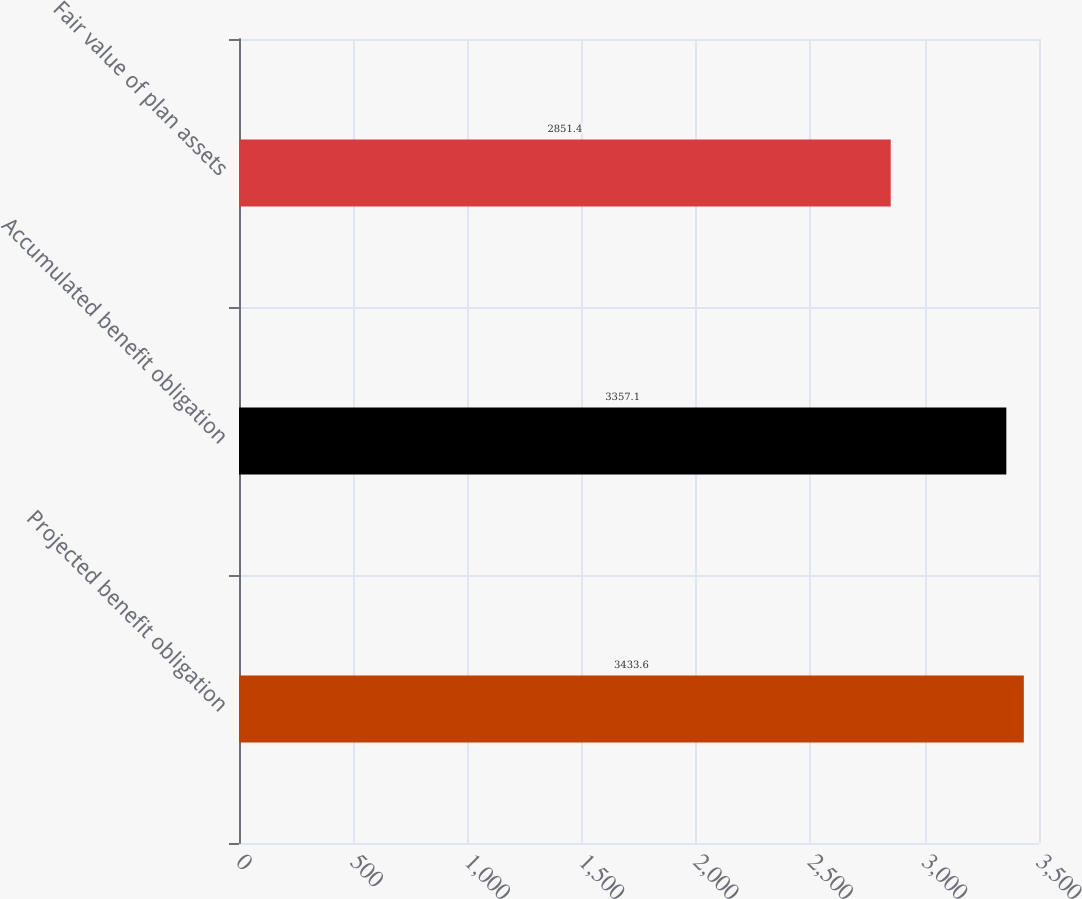<chart> <loc_0><loc_0><loc_500><loc_500><bar_chart><fcel>Projected benefit obligation<fcel>Accumulated benefit obligation<fcel>Fair value of plan assets<nl><fcel>3433.6<fcel>3357.1<fcel>2851.4<nl></chart> 